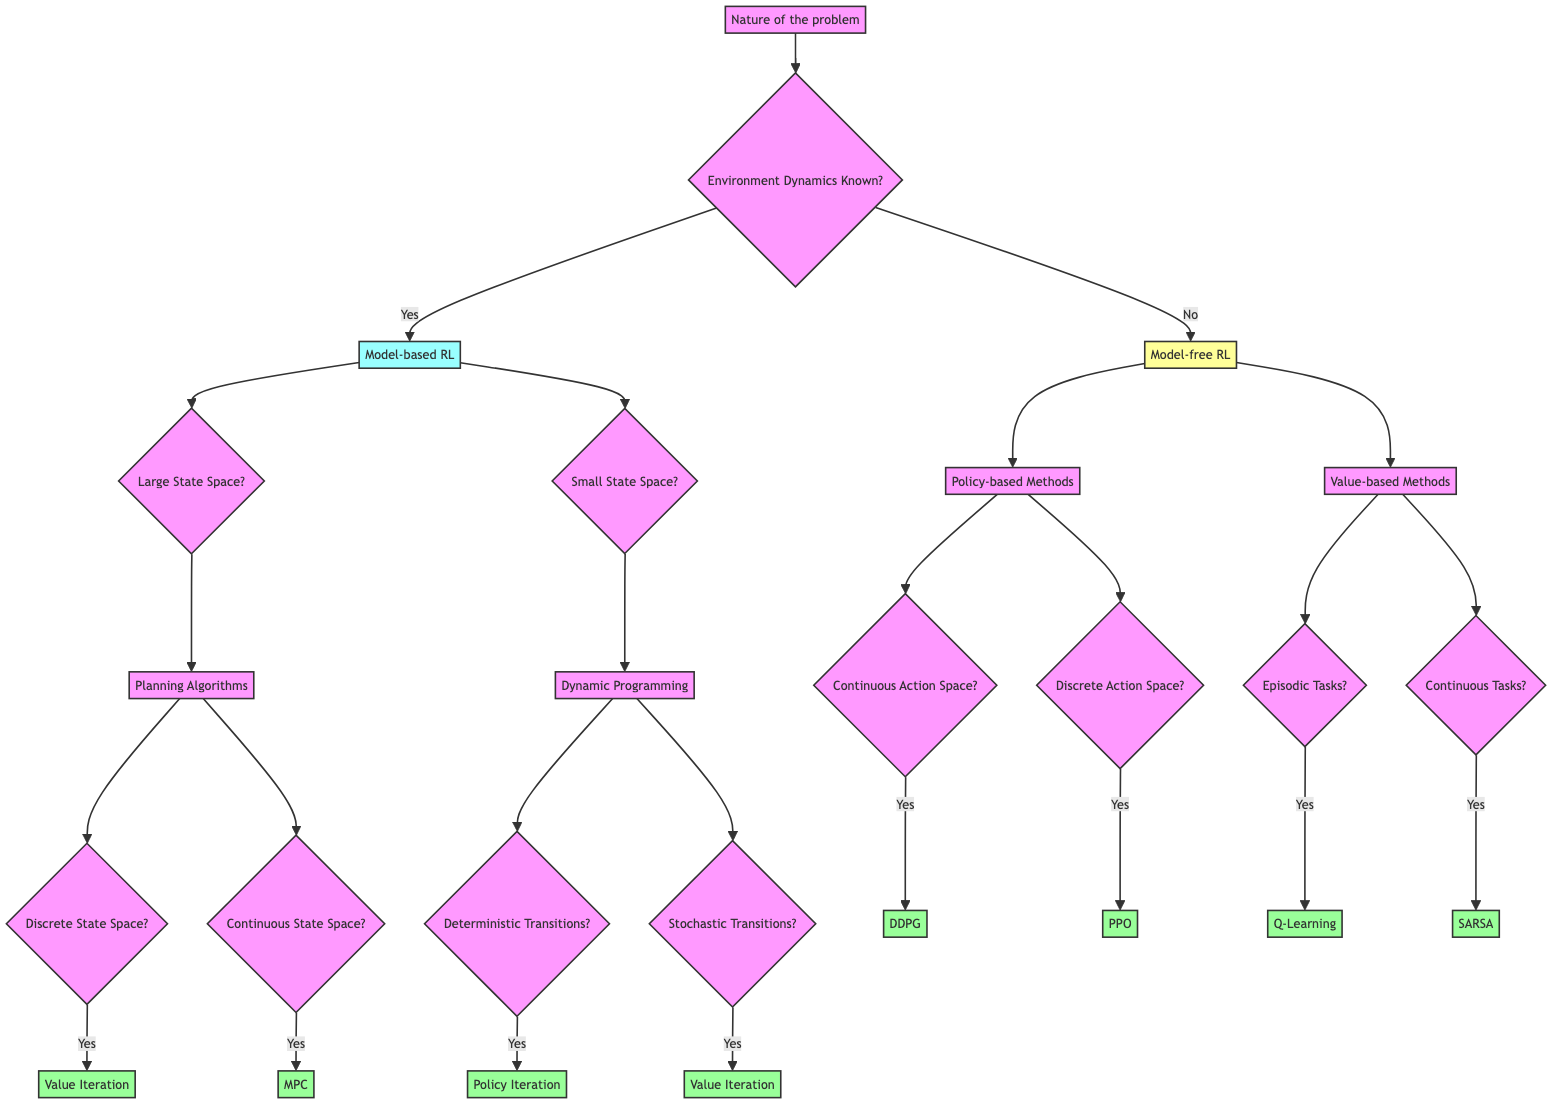What are the two branches under "Environment Dynamics Known"? The two branches are "Model-based RL" and "Model-free RL". These branches represent the decision point for whether the dynamics of the environment are known or not.
Answer: Model-based RL, Model-free RL What type of RL is suggested for a large state space with known dynamics? When the environment dynamics are known and the state space is large, the diagram indicates the use of "Planning Algorithms". This indicates that a model-based approach is being taken.
Answer: Planning Algorithms How many types of algorithms are listed under "Model-free RL"? Under "Model-free RL", two types of methods are listed: "Policy-based Methods" and "Value-based Methods". Therefore, there are two types of algorithms.
Answer: 2 What is the result if the transitions are stochastic with a small state space? If the transitions are stochastic and the state space is small, the decision tree leads to "Value Iteration". This indicates the approach to take when faced with these conditions.
Answer: Value Iteration Which algorithm is recommended for continuous action space under "Policy-based Methods"? Under "Policy-based Methods", for a continuous action space, the diagram recommends "DDPG". This specifically addresses continuous action scenarios.
Answer: DDPG If the environment dynamics are unknown and the task is episodic, what algorithm should be selected? When the environment dynamics are unknown and the task is episodic, the diagram directs you to "Q-Learning". This indicates it's suitable for such tasks when dynamics are not specified.
Answer: Q-Learning What path would you take for a small state space with deterministic transitions? For a small state space with deterministic transitions, the diagram shows that the path leads to "Policy Iteration". This denotes the specific algorithm for these conditions.
Answer: Policy Iteration How many leaves are there in total for all suggested algorithms? Counting the leaves from the diagram, there are 7 distinct leaf nodes: Value Iteration, MPC, Policy Iteration, Value Iteration, DDPG, PPO, and SARSA. Therefore, the total number is seven leaves.
Answer: 7 Which branch connects to "PPO"? "PPO" is connected through the branch of "Policy-based Methods" and under the condition of "Discrete Action Space". Therefore, it branches from policy-based methods based on the nature of the action space.
Answer: Policy-based Methods, Discrete Action Space 